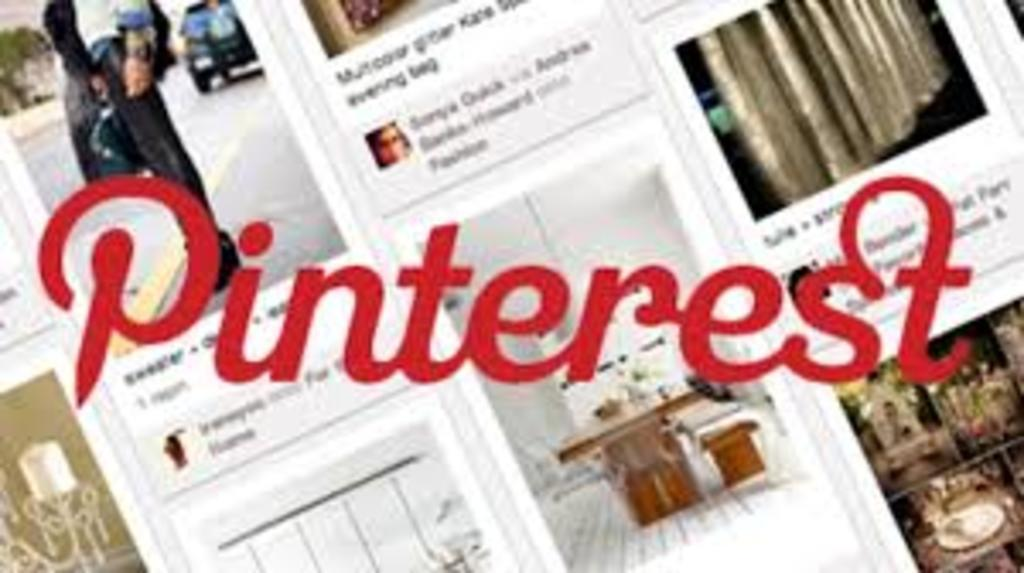What can be observed about the nature of the image? The image is edited. What types of visual elements are present in the image? There are pictures and text in the image. What type of oven is visible in the image? There is no oven present in the image. What material is the steel sign made of in the image? There is no steel sign present in the image. 